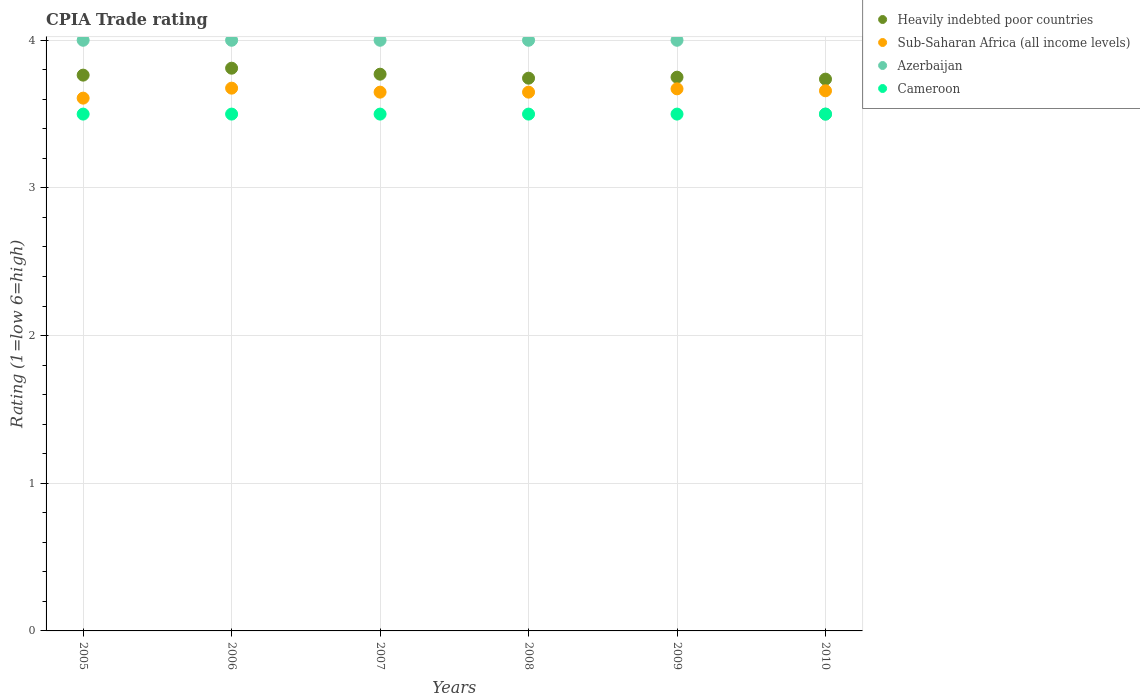How many different coloured dotlines are there?
Your answer should be very brief. 4. Is the number of dotlines equal to the number of legend labels?
Give a very brief answer. Yes. What is the CPIA rating in Heavily indebted poor countries in 2010?
Give a very brief answer. 3.74. Across all years, what is the maximum CPIA rating in Heavily indebted poor countries?
Your answer should be very brief. 3.81. Across all years, what is the minimum CPIA rating in Sub-Saharan Africa (all income levels)?
Offer a very short reply. 3.61. What is the total CPIA rating in Sub-Saharan Africa (all income levels) in the graph?
Ensure brevity in your answer.  21.91. What is the difference between the CPIA rating in Heavily indebted poor countries in 2006 and that in 2008?
Make the answer very short. 0.07. What is the difference between the CPIA rating in Heavily indebted poor countries in 2007 and the CPIA rating in Cameroon in 2010?
Your answer should be compact. 0.27. What is the average CPIA rating in Azerbaijan per year?
Your response must be concise. 3.92. In the year 2010, what is the difference between the CPIA rating in Heavily indebted poor countries and CPIA rating in Azerbaijan?
Your answer should be very brief. 0.24. Is the CPIA rating in Cameroon strictly greater than the CPIA rating in Sub-Saharan Africa (all income levels) over the years?
Offer a very short reply. No. How many dotlines are there?
Ensure brevity in your answer.  4. How many years are there in the graph?
Give a very brief answer. 6. Are the values on the major ticks of Y-axis written in scientific E-notation?
Your answer should be very brief. No. How many legend labels are there?
Your response must be concise. 4. What is the title of the graph?
Provide a short and direct response. CPIA Trade rating. Does "India" appear as one of the legend labels in the graph?
Keep it short and to the point. No. What is the label or title of the X-axis?
Your answer should be compact. Years. What is the Rating (1=low 6=high) of Heavily indebted poor countries in 2005?
Offer a terse response. 3.76. What is the Rating (1=low 6=high) of Sub-Saharan Africa (all income levels) in 2005?
Give a very brief answer. 3.61. What is the Rating (1=low 6=high) in Heavily indebted poor countries in 2006?
Offer a terse response. 3.81. What is the Rating (1=low 6=high) of Sub-Saharan Africa (all income levels) in 2006?
Give a very brief answer. 3.68. What is the Rating (1=low 6=high) in Azerbaijan in 2006?
Your answer should be very brief. 4. What is the Rating (1=low 6=high) in Heavily indebted poor countries in 2007?
Give a very brief answer. 3.77. What is the Rating (1=low 6=high) of Sub-Saharan Africa (all income levels) in 2007?
Make the answer very short. 3.65. What is the Rating (1=low 6=high) of Cameroon in 2007?
Give a very brief answer. 3.5. What is the Rating (1=low 6=high) in Heavily indebted poor countries in 2008?
Your answer should be very brief. 3.74. What is the Rating (1=low 6=high) of Sub-Saharan Africa (all income levels) in 2008?
Keep it short and to the point. 3.65. What is the Rating (1=low 6=high) of Azerbaijan in 2008?
Give a very brief answer. 4. What is the Rating (1=low 6=high) of Cameroon in 2008?
Offer a terse response. 3.5. What is the Rating (1=low 6=high) in Heavily indebted poor countries in 2009?
Your response must be concise. 3.75. What is the Rating (1=low 6=high) of Sub-Saharan Africa (all income levels) in 2009?
Your answer should be compact. 3.67. What is the Rating (1=low 6=high) in Cameroon in 2009?
Offer a terse response. 3.5. What is the Rating (1=low 6=high) in Heavily indebted poor countries in 2010?
Ensure brevity in your answer.  3.74. What is the Rating (1=low 6=high) in Sub-Saharan Africa (all income levels) in 2010?
Your answer should be very brief. 3.66. What is the Rating (1=low 6=high) in Azerbaijan in 2010?
Provide a succinct answer. 3.5. What is the Rating (1=low 6=high) in Cameroon in 2010?
Your answer should be compact. 3.5. Across all years, what is the maximum Rating (1=low 6=high) of Heavily indebted poor countries?
Provide a short and direct response. 3.81. Across all years, what is the maximum Rating (1=low 6=high) of Sub-Saharan Africa (all income levels)?
Provide a short and direct response. 3.68. Across all years, what is the maximum Rating (1=low 6=high) in Azerbaijan?
Ensure brevity in your answer.  4. Across all years, what is the minimum Rating (1=low 6=high) in Heavily indebted poor countries?
Provide a succinct answer. 3.74. Across all years, what is the minimum Rating (1=low 6=high) in Sub-Saharan Africa (all income levels)?
Your response must be concise. 3.61. Across all years, what is the minimum Rating (1=low 6=high) of Azerbaijan?
Your response must be concise. 3.5. What is the total Rating (1=low 6=high) of Heavily indebted poor countries in the graph?
Keep it short and to the point. 22.58. What is the total Rating (1=low 6=high) in Sub-Saharan Africa (all income levels) in the graph?
Provide a short and direct response. 21.91. What is the total Rating (1=low 6=high) of Cameroon in the graph?
Give a very brief answer. 21. What is the difference between the Rating (1=low 6=high) of Heavily indebted poor countries in 2005 and that in 2006?
Your answer should be very brief. -0.05. What is the difference between the Rating (1=low 6=high) in Sub-Saharan Africa (all income levels) in 2005 and that in 2006?
Offer a very short reply. -0.07. What is the difference between the Rating (1=low 6=high) of Cameroon in 2005 and that in 2006?
Give a very brief answer. 0. What is the difference between the Rating (1=low 6=high) of Heavily indebted poor countries in 2005 and that in 2007?
Your response must be concise. -0.01. What is the difference between the Rating (1=low 6=high) of Sub-Saharan Africa (all income levels) in 2005 and that in 2007?
Give a very brief answer. -0.04. What is the difference between the Rating (1=low 6=high) in Cameroon in 2005 and that in 2007?
Ensure brevity in your answer.  0. What is the difference between the Rating (1=low 6=high) of Heavily indebted poor countries in 2005 and that in 2008?
Give a very brief answer. 0.02. What is the difference between the Rating (1=low 6=high) of Sub-Saharan Africa (all income levels) in 2005 and that in 2008?
Your response must be concise. -0.04. What is the difference between the Rating (1=low 6=high) of Azerbaijan in 2005 and that in 2008?
Ensure brevity in your answer.  0. What is the difference between the Rating (1=low 6=high) of Heavily indebted poor countries in 2005 and that in 2009?
Keep it short and to the point. 0.01. What is the difference between the Rating (1=low 6=high) of Sub-Saharan Africa (all income levels) in 2005 and that in 2009?
Your answer should be compact. -0.06. What is the difference between the Rating (1=low 6=high) in Azerbaijan in 2005 and that in 2009?
Keep it short and to the point. 0. What is the difference between the Rating (1=low 6=high) in Heavily indebted poor countries in 2005 and that in 2010?
Offer a very short reply. 0.03. What is the difference between the Rating (1=low 6=high) of Sub-Saharan Africa (all income levels) in 2005 and that in 2010?
Your answer should be very brief. -0.05. What is the difference between the Rating (1=low 6=high) in Azerbaijan in 2005 and that in 2010?
Your answer should be very brief. 0.5. What is the difference between the Rating (1=low 6=high) of Heavily indebted poor countries in 2006 and that in 2007?
Give a very brief answer. 0.04. What is the difference between the Rating (1=low 6=high) of Sub-Saharan Africa (all income levels) in 2006 and that in 2007?
Give a very brief answer. 0.03. What is the difference between the Rating (1=low 6=high) of Azerbaijan in 2006 and that in 2007?
Keep it short and to the point. 0. What is the difference between the Rating (1=low 6=high) of Cameroon in 2006 and that in 2007?
Your answer should be compact. 0. What is the difference between the Rating (1=low 6=high) of Heavily indebted poor countries in 2006 and that in 2008?
Your answer should be very brief. 0.07. What is the difference between the Rating (1=low 6=high) of Sub-Saharan Africa (all income levels) in 2006 and that in 2008?
Make the answer very short. 0.03. What is the difference between the Rating (1=low 6=high) of Heavily indebted poor countries in 2006 and that in 2009?
Your answer should be very brief. 0.06. What is the difference between the Rating (1=low 6=high) in Sub-Saharan Africa (all income levels) in 2006 and that in 2009?
Offer a terse response. 0. What is the difference between the Rating (1=low 6=high) of Heavily indebted poor countries in 2006 and that in 2010?
Provide a short and direct response. 0.07. What is the difference between the Rating (1=low 6=high) of Sub-Saharan Africa (all income levels) in 2006 and that in 2010?
Ensure brevity in your answer.  0.02. What is the difference between the Rating (1=low 6=high) in Heavily indebted poor countries in 2007 and that in 2008?
Your answer should be compact. 0.03. What is the difference between the Rating (1=low 6=high) in Azerbaijan in 2007 and that in 2008?
Keep it short and to the point. 0. What is the difference between the Rating (1=low 6=high) in Heavily indebted poor countries in 2007 and that in 2009?
Your response must be concise. 0.02. What is the difference between the Rating (1=low 6=high) in Sub-Saharan Africa (all income levels) in 2007 and that in 2009?
Provide a succinct answer. -0.02. What is the difference between the Rating (1=low 6=high) in Azerbaijan in 2007 and that in 2009?
Your answer should be compact. 0. What is the difference between the Rating (1=low 6=high) in Cameroon in 2007 and that in 2009?
Your response must be concise. 0. What is the difference between the Rating (1=low 6=high) in Heavily indebted poor countries in 2007 and that in 2010?
Keep it short and to the point. 0.03. What is the difference between the Rating (1=low 6=high) of Sub-Saharan Africa (all income levels) in 2007 and that in 2010?
Make the answer very short. -0.01. What is the difference between the Rating (1=low 6=high) in Azerbaijan in 2007 and that in 2010?
Your answer should be very brief. 0.5. What is the difference between the Rating (1=low 6=high) of Heavily indebted poor countries in 2008 and that in 2009?
Ensure brevity in your answer.  -0.01. What is the difference between the Rating (1=low 6=high) of Sub-Saharan Africa (all income levels) in 2008 and that in 2009?
Ensure brevity in your answer.  -0.02. What is the difference between the Rating (1=low 6=high) in Azerbaijan in 2008 and that in 2009?
Provide a short and direct response. 0. What is the difference between the Rating (1=low 6=high) in Heavily indebted poor countries in 2008 and that in 2010?
Your answer should be compact. 0.01. What is the difference between the Rating (1=low 6=high) of Sub-Saharan Africa (all income levels) in 2008 and that in 2010?
Ensure brevity in your answer.  -0.01. What is the difference between the Rating (1=low 6=high) of Azerbaijan in 2008 and that in 2010?
Your response must be concise. 0.5. What is the difference between the Rating (1=low 6=high) of Heavily indebted poor countries in 2009 and that in 2010?
Offer a very short reply. 0.01. What is the difference between the Rating (1=low 6=high) of Sub-Saharan Africa (all income levels) in 2009 and that in 2010?
Give a very brief answer. 0.01. What is the difference between the Rating (1=low 6=high) in Azerbaijan in 2009 and that in 2010?
Your answer should be compact. 0.5. What is the difference between the Rating (1=low 6=high) of Cameroon in 2009 and that in 2010?
Your answer should be compact. 0. What is the difference between the Rating (1=low 6=high) of Heavily indebted poor countries in 2005 and the Rating (1=low 6=high) of Sub-Saharan Africa (all income levels) in 2006?
Offer a very short reply. 0.09. What is the difference between the Rating (1=low 6=high) in Heavily indebted poor countries in 2005 and the Rating (1=low 6=high) in Azerbaijan in 2006?
Give a very brief answer. -0.24. What is the difference between the Rating (1=low 6=high) of Heavily indebted poor countries in 2005 and the Rating (1=low 6=high) of Cameroon in 2006?
Keep it short and to the point. 0.26. What is the difference between the Rating (1=low 6=high) in Sub-Saharan Africa (all income levels) in 2005 and the Rating (1=low 6=high) in Azerbaijan in 2006?
Give a very brief answer. -0.39. What is the difference between the Rating (1=low 6=high) of Sub-Saharan Africa (all income levels) in 2005 and the Rating (1=low 6=high) of Cameroon in 2006?
Keep it short and to the point. 0.11. What is the difference between the Rating (1=low 6=high) in Azerbaijan in 2005 and the Rating (1=low 6=high) in Cameroon in 2006?
Offer a terse response. 0.5. What is the difference between the Rating (1=low 6=high) of Heavily indebted poor countries in 2005 and the Rating (1=low 6=high) of Sub-Saharan Africa (all income levels) in 2007?
Offer a very short reply. 0.12. What is the difference between the Rating (1=low 6=high) in Heavily indebted poor countries in 2005 and the Rating (1=low 6=high) in Azerbaijan in 2007?
Your response must be concise. -0.24. What is the difference between the Rating (1=low 6=high) in Heavily indebted poor countries in 2005 and the Rating (1=low 6=high) in Cameroon in 2007?
Give a very brief answer. 0.26. What is the difference between the Rating (1=low 6=high) of Sub-Saharan Africa (all income levels) in 2005 and the Rating (1=low 6=high) of Azerbaijan in 2007?
Provide a succinct answer. -0.39. What is the difference between the Rating (1=low 6=high) of Sub-Saharan Africa (all income levels) in 2005 and the Rating (1=low 6=high) of Cameroon in 2007?
Keep it short and to the point. 0.11. What is the difference between the Rating (1=low 6=high) in Heavily indebted poor countries in 2005 and the Rating (1=low 6=high) in Sub-Saharan Africa (all income levels) in 2008?
Provide a succinct answer. 0.12. What is the difference between the Rating (1=low 6=high) of Heavily indebted poor countries in 2005 and the Rating (1=low 6=high) of Azerbaijan in 2008?
Offer a terse response. -0.24. What is the difference between the Rating (1=low 6=high) of Heavily indebted poor countries in 2005 and the Rating (1=low 6=high) of Cameroon in 2008?
Provide a succinct answer. 0.26. What is the difference between the Rating (1=low 6=high) in Sub-Saharan Africa (all income levels) in 2005 and the Rating (1=low 6=high) in Azerbaijan in 2008?
Your answer should be very brief. -0.39. What is the difference between the Rating (1=low 6=high) of Sub-Saharan Africa (all income levels) in 2005 and the Rating (1=low 6=high) of Cameroon in 2008?
Give a very brief answer. 0.11. What is the difference between the Rating (1=low 6=high) of Azerbaijan in 2005 and the Rating (1=low 6=high) of Cameroon in 2008?
Provide a short and direct response. 0.5. What is the difference between the Rating (1=low 6=high) of Heavily indebted poor countries in 2005 and the Rating (1=low 6=high) of Sub-Saharan Africa (all income levels) in 2009?
Offer a very short reply. 0.09. What is the difference between the Rating (1=low 6=high) in Heavily indebted poor countries in 2005 and the Rating (1=low 6=high) in Azerbaijan in 2009?
Give a very brief answer. -0.24. What is the difference between the Rating (1=low 6=high) in Heavily indebted poor countries in 2005 and the Rating (1=low 6=high) in Cameroon in 2009?
Your answer should be very brief. 0.26. What is the difference between the Rating (1=low 6=high) of Sub-Saharan Africa (all income levels) in 2005 and the Rating (1=low 6=high) of Azerbaijan in 2009?
Provide a short and direct response. -0.39. What is the difference between the Rating (1=low 6=high) in Sub-Saharan Africa (all income levels) in 2005 and the Rating (1=low 6=high) in Cameroon in 2009?
Your answer should be very brief. 0.11. What is the difference between the Rating (1=low 6=high) of Azerbaijan in 2005 and the Rating (1=low 6=high) of Cameroon in 2009?
Ensure brevity in your answer.  0.5. What is the difference between the Rating (1=low 6=high) of Heavily indebted poor countries in 2005 and the Rating (1=low 6=high) of Sub-Saharan Africa (all income levels) in 2010?
Provide a short and direct response. 0.11. What is the difference between the Rating (1=low 6=high) in Heavily indebted poor countries in 2005 and the Rating (1=low 6=high) in Azerbaijan in 2010?
Your response must be concise. 0.26. What is the difference between the Rating (1=low 6=high) in Heavily indebted poor countries in 2005 and the Rating (1=low 6=high) in Cameroon in 2010?
Provide a short and direct response. 0.26. What is the difference between the Rating (1=low 6=high) in Sub-Saharan Africa (all income levels) in 2005 and the Rating (1=low 6=high) in Azerbaijan in 2010?
Provide a succinct answer. 0.11. What is the difference between the Rating (1=low 6=high) in Sub-Saharan Africa (all income levels) in 2005 and the Rating (1=low 6=high) in Cameroon in 2010?
Offer a very short reply. 0.11. What is the difference between the Rating (1=low 6=high) of Azerbaijan in 2005 and the Rating (1=low 6=high) of Cameroon in 2010?
Offer a very short reply. 0.5. What is the difference between the Rating (1=low 6=high) in Heavily indebted poor countries in 2006 and the Rating (1=low 6=high) in Sub-Saharan Africa (all income levels) in 2007?
Keep it short and to the point. 0.16. What is the difference between the Rating (1=low 6=high) of Heavily indebted poor countries in 2006 and the Rating (1=low 6=high) of Azerbaijan in 2007?
Keep it short and to the point. -0.19. What is the difference between the Rating (1=low 6=high) in Heavily indebted poor countries in 2006 and the Rating (1=low 6=high) in Cameroon in 2007?
Provide a succinct answer. 0.31. What is the difference between the Rating (1=low 6=high) in Sub-Saharan Africa (all income levels) in 2006 and the Rating (1=low 6=high) in Azerbaijan in 2007?
Offer a very short reply. -0.32. What is the difference between the Rating (1=low 6=high) in Sub-Saharan Africa (all income levels) in 2006 and the Rating (1=low 6=high) in Cameroon in 2007?
Provide a short and direct response. 0.18. What is the difference between the Rating (1=low 6=high) in Azerbaijan in 2006 and the Rating (1=low 6=high) in Cameroon in 2007?
Give a very brief answer. 0.5. What is the difference between the Rating (1=low 6=high) of Heavily indebted poor countries in 2006 and the Rating (1=low 6=high) of Sub-Saharan Africa (all income levels) in 2008?
Keep it short and to the point. 0.16. What is the difference between the Rating (1=low 6=high) of Heavily indebted poor countries in 2006 and the Rating (1=low 6=high) of Azerbaijan in 2008?
Provide a succinct answer. -0.19. What is the difference between the Rating (1=low 6=high) in Heavily indebted poor countries in 2006 and the Rating (1=low 6=high) in Cameroon in 2008?
Offer a terse response. 0.31. What is the difference between the Rating (1=low 6=high) in Sub-Saharan Africa (all income levels) in 2006 and the Rating (1=low 6=high) in Azerbaijan in 2008?
Make the answer very short. -0.32. What is the difference between the Rating (1=low 6=high) of Sub-Saharan Africa (all income levels) in 2006 and the Rating (1=low 6=high) of Cameroon in 2008?
Your response must be concise. 0.18. What is the difference between the Rating (1=low 6=high) in Heavily indebted poor countries in 2006 and the Rating (1=low 6=high) in Sub-Saharan Africa (all income levels) in 2009?
Provide a succinct answer. 0.14. What is the difference between the Rating (1=low 6=high) in Heavily indebted poor countries in 2006 and the Rating (1=low 6=high) in Azerbaijan in 2009?
Provide a short and direct response. -0.19. What is the difference between the Rating (1=low 6=high) of Heavily indebted poor countries in 2006 and the Rating (1=low 6=high) of Cameroon in 2009?
Provide a short and direct response. 0.31. What is the difference between the Rating (1=low 6=high) of Sub-Saharan Africa (all income levels) in 2006 and the Rating (1=low 6=high) of Azerbaijan in 2009?
Offer a terse response. -0.32. What is the difference between the Rating (1=low 6=high) in Sub-Saharan Africa (all income levels) in 2006 and the Rating (1=low 6=high) in Cameroon in 2009?
Provide a succinct answer. 0.18. What is the difference between the Rating (1=low 6=high) of Heavily indebted poor countries in 2006 and the Rating (1=low 6=high) of Sub-Saharan Africa (all income levels) in 2010?
Your response must be concise. 0.15. What is the difference between the Rating (1=low 6=high) of Heavily indebted poor countries in 2006 and the Rating (1=low 6=high) of Azerbaijan in 2010?
Provide a succinct answer. 0.31. What is the difference between the Rating (1=low 6=high) in Heavily indebted poor countries in 2006 and the Rating (1=low 6=high) in Cameroon in 2010?
Your answer should be very brief. 0.31. What is the difference between the Rating (1=low 6=high) in Sub-Saharan Africa (all income levels) in 2006 and the Rating (1=low 6=high) in Azerbaijan in 2010?
Keep it short and to the point. 0.18. What is the difference between the Rating (1=low 6=high) in Sub-Saharan Africa (all income levels) in 2006 and the Rating (1=low 6=high) in Cameroon in 2010?
Your answer should be very brief. 0.18. What is the difference between the Rating (1=low 6=high) in Azerbaijan in 2006 and the Rating (1=low 6=high) in Cameroon in 2010?
Make the answer very short. 0.5. What is the difference between the Rating (1=low 6=high) of Heavily indebted poor countries in 2007 and the Rating (1=low 6=high) of Sub-Saharan Africa (all income levels) in 2008?
Provide a succinct answer. 0.12. What is the difference between the Rating (1=low 6=high) of Heavily indebted poor countries in 2007 and the Rating (1=low 6=high) of Azerbaijan in 2008?
Provide a succinct answer. -0.23. What is the difference between the Rating (1=low 6=high) in Heavily indebted poor countries in 2007 and the Rating (1=low 6=high) in Cameroon in 2008?
Provide a succinct answer. 0.27. What is the difference between the Rating (1=low 6=high) in Sub-Saharan Africa (all income levels) in 2007 and the Rating (1=low 6=high) in Azerbaijan in 2008?
Offer a terse response. -0.35. What is the difference between the Rating (1=low 6=high) of Sub-Saharan Africa (all income levels) in 2007 and the Rating (1=low 6=high) of Cameroon in 2008?
Give a very brief answer. 0.15. What is the difference between the Rating (1=low 6=high) in Azerbaijan in 2007 and the Rating (1=low 6=high) in Cameroon in 2008?
Offer a terse response. 0.5. What is the difference between the Rating (1=low 6=high) of Heavily indebted poor countries in 2007 and the Rating (1=low 6=high) of Sub-Saharan Africa (all income levels) in 2009?
Keep it short and to the point. 0.1. What is the difference between the Rating (1=low 6=high) of Heavily indebted poor countries in 2007 and the Rating (1=low 6=high) of Azerbaijan in 2009?
Provide a succinct answer. -0.23. What is the difference between the Rating (1=low 6=high) of Heavily indebted poor countries in 2007 and the Rating (1=low 6=high) of Cameroon in 2009?
Your response must be concise. 0.27. What is the difference between the Rating (1=low 6=high) of Sub-Saharan Africa (all income levels) in 2007 and the Rating (1=low 6=high) of Azerbaijan in 2009?
Give a very brief answer. -0.35. What is the difference between the Rating (1=low 6=high) in Sub-Saharan Africa (all income levels) in 2007 and the Rating (1=low 6=high) in Cameroon in 2009?
Offer a very short reply. 0.15. What is the difference between the Rating (1=low 6=high) of Heavily indebted poor countries in 2007 and the Rating (1=low 6=high) of Sub-Saharan Africa (all income levels) in 2010?
Provide a succinct answer. 0.11. What is the difference between the Rating (1=low 6=high) of Heavily indebted poor countries in 2007 and the Rating (1=low 6=high) of Azerbaijan in 2010?
Give a very brief answer. 0.27. What is the difference between the Rating (1=low 6=high) in Heavily indebted poor countries in 2007 and the Rating (1=low 6=high) in Cameroon in 2010?
Your answer should be compact. 0.27. What is the difference between the Rating (1=low 6=high) of Sub-Saharan Africa (all income levels) in 2007 and the Rating (1=low 6=high) of Azerbaijan in 2010?
Offer a terse response. 0.15. What is the difference between the Rating (1=low 6=high) of Sub-Saharan Africa (all income levels) in 2007 and the Rating (1=low 6=high) of Cameroon in 2010?
Your response must be concise. 0.15. What is the difference between the Rating (1=low 6=high) in Heavily indebted poor countries in 2008 and the Rating (1=low 6=high) in Sub-Saharan Africa (all income levels) in 2009?
Your answer should be very brief. 0.07. What is the difference between the Rating (1=low 6=high) in Heavily indebted poor countries in 2008 and the Rating (1=low 6=high) in Azerbaijan in 2009?
Your answer should be very brief. -0.26. What is the difference between the Rating (1=low 6=high) in Heavily indebted poor countries in 2008 and the Rating (1=low 6=high) in Cameroon in 2009?
Offer a very short reply. 0.24. What is the difference between the Rating (1=low 6=high) in Sub-Saharan Africa (all income levels) in 2008 and the Rating (1=low 6=high) in Azerbaijan in 2009?
Your answer should be compact. -0.35. What is the difference between the Rating (1=low 6=high) of Sub-Saharan Africa (all income levels) in 2008 and the Rating (1=low 6=high) of Cameroon in 2009?
Your response must be concise. 0.15. What is the difference between the Rating (1=low 6=high) of Azerbaijan in 2008 and the Rating (1=low 6=high) of Cameroon in 2009?
Provide a short and direct response. 0.5. What is the difference between the Rating (1=low 6=high) of Heavily indebted poor countries in 2008 and the Rating (1=low 6=high) of Sub-Saharan Africa (all income levels) in 2010?
Offer a very short reply. 0.09. What is the difference between the Rating (1=low 6=high) of Heavily indebted poor countries in 2008 and the Rating (1=low 6=high) of Azerbaijan in 2010?
Your answer should be very brief. 0.24. What is the difference between the Rating (1=low 6=high) of Heavily indebted poor countries in 2008 and the Rating (1=low 6=high) of Cameroon in 2010?
Your response must be concise. 0.24. What is the difference between the Rating (1=low 6=high) in Sub-Saharan Africa (all income levels) in 2008 and the Rating (1=low 6=high) in Azerbaijan in 2010?
Ensure brevity in your answer.  0.15. What is the difference between the Rating (1=low 6=high) of Sub-Saharan Africa (all income levels) in 2008 and the Rating (1=low 6=high) of Cameroon in 2010?
Give a very brief answer. 0.15. What is the difference between the Rating (1=low 6=high) in Heavily indebted poor countries in 2009 and the Rating (1=low 6=high) in Sub-Saharan Africa (all income levels) in 2010?
Your answer should be very brief. 0.09. What is the difference between the Rating (1=low 6=high) of Heavily indebted poor countries in 2009 and the Rating (1=low 6=high) of Cameroon in 2010?
Provide a succinct answer. 0.25. What is the difference between the Rating (1=low 6=high) of Sub-Saharan Africa (all income levels) in 2009 and the Rating (1=low 6=high) of Azerbaijan in 2010?
Your answer should be very brief. 0.17. What is the difference between the Rating (1=low 6=high) in Sub-Saharan Africa (all income levels) in 2009 and the Rating (1=low 6=high) in Cameroon in 2010?
Offer a terse response. 0.17. What is the difference between the Rating (1=low 6=high) in Azerbaijan in 2009 and the Rating (1=low 6=high) in Cameroon in 2010?
Provide a succinct answer. 0.5. What is the average Rating (1=low 6=high) of Heavily indebted poor countries per year?
Your response must be concise. 3.76. What is the average Rating (1=low 6=high) in Sub-Saharan Africa (all income levels) per year?
Give a very brief answer. 3.65. What is the average Rating (1=low 6=high) in Azerbaijan per year?
Your answer should be very brief. 3.92. In the year 2005, what is the difference between the Rating (1=low 6=high) of Heavily indebted poor countries and Rating (1=low 6=high) of Sub-Saharan Africa (all income levels)?
Your response must be concise. 0.16. In the year 2005, what is the difference between the Rating (1=low 6=high) of Heavily indebted poor countries and Rating (1=low 6=high) of Azerbaijan?
Provide a short and direct response. -0.24. In the year 2005, what is the difference between the Rating (1=low 6=high) of Heavily indebted poor countries and Rating (1=low 6=high) of Cameroon?
Offer a terse response. 0.26. In the year 2005, what is the difference between the Rating (1=low 6=high) of Sub-Saharan Africa (all income levels) and Rating (1=low 6=high) of Azerbaijan?
Ensure brevity in your answer.  -0.39. In the year 2005, what is the difference between the Rating (1=low 6=high) in Sub-Saharan Africa (all income levels) and Rating (1=low 6=high) in Cameroon?
Offer a very short reply. 0.11. In the year 2006, what is the difference between the Rating (1=low 6=high) in Heavily indebted poor countries and Rating (1=low 6=high) in Sub-Saharan Africa (all income levels)?
Give a very brief answer. 0.14. In the year 2006, what is the difference between the Rating (1=low 6=high) in Heavily indebted poor countries and Rating (1=low 6=high) in Azerbaijan?
Make the answer very short. -0.19. In the year 2006, what is the difference between the Rating (1=low 6=high) in Heavily indebted poor countries and Rating (1=low 6=high) in Cameroon?
Give a very brief answer. 0.31. In the year 2006, what is the difference between the Rating (1=low 6=high) of Sub-Saharan Africa (all income levels) and Rating (1=low 6=high) of Azerbaijan?
Give a very brief answer. -0.32. In the year 2006, what is the difference between the Rating (1=low 6=high) of Sub-Saharan Africa (all income levels) and Rating (1=low 6=high) of Cameroon?
Provide a succinct answer. 0.18. In the year 2006, what is the difference between the Rating (1=low 6=high) in Azerbaijan and Rating (1=low 6=high) in Cameroon?
Your response must be concise. 0.5. In the year 2007, what is the difference between the Rating (1=low 6=high) of Heavily indebted poor countries and Rating (1=low 6=high) of Sub-Saharan Africa (all income levels)?
Give a very brief answer. 0.12. In the year 2007, what is the difference between the Rating (1=low 6=high) in Heavily indebted poor countries and Rating (1=low 6=high) in Azerbaijan?
Make the answer very short. -0.23. In the year 2007, what is the difference between the Rating (1=low 6=high) of Heavily indebted poor countries and Rating (1=low 6=high) of Cameroon?
Your answer should be very brief. 0.27. In the year 2007, what is the difference between the Rating (1=low 6=high) of Sub-Saharan Africa (all income levels) and Rating (1=low 6=high) of Azerbaijan?
Give a very brief answer. -0.35. In the year 2007, what is the difference between the Rating (1=low 6=high) in Sub-Saharan Africa (all income levels) and Rating (1=low 6=high) in Cameroon?
Your answer should be very brief. 0.15. In the year 2008, what is the difference between the Rating (1=low 6=high) of Heavily indebted poor countries and Rating (1=low 6=high) of Sub-Saharan Africa (all income levels)?
Ensure brevity in your answer.  0.09. In the year 2008, what is the difference between the Rating (1=low 6=high) of Heavily indebted poor countries and Rating (1=low 6=high) of Azerbaijan?
Offer a very short reply. -0.26. In the year 2008, what is the difference between the Rating (1=low 6=high) in Heavily indebted poor countries and Rating (1=low 6=high) in Cameroon?
Offer a terse response. 0.24. In the year 2008, what is the difference between the Rating (1=low 6=high) in Sub-Saharan Africa (all income levels) and Rating (1=low 6=high) in Azerbaijan?
Offer a very short reply. -0.35. In the year 2008, what is the difference between the Rating (1=low 6=high) of Sub-Saharan Africa (all income levels) and Rating (1=low 6=high) of Cameroon?
Keep it short and to the point. 0.15. In the year 2008, what is the difference between the Rating (1=low 6=high) of Azerbaijan and Rating (1=low 6=high) of Cameroon?
Offer a terse response. 0.5. In the year 2009, what is the difference between the Rating (1=low 6=high) of Heavily indebted poor countries and Rating (1=low 6=high) of Sub-Saharan Africa (all income levels)?
Offer a terse response. 0.08. In the year 2009, what is the difference between the Rating (1=low 6=high) in Heavily indebted poor countries and Rating (1=low 6=high) in Cameroon?
Keep it short and to the point. 0.25. In the year 2009, what is the difference between the Rating (1=low 6=high) of Sub-Saharan Africa (all income levels) and Rating (1=low 6=high) of Azerbaijan?
Ensure brevity in your answer.  -0.33. In the year 2009, what is the difference between the Rating (1=low 6=high) in Sub-Saharan Africa (all income levels) and Rating (1=low 6=high) in Cameroon?
Make the answer very short. 0.17. In the year 2010, what is the difference between the Rating (1=low 6=high) in Heavily indebted poor countries and Rating (1=low 6=high) in Sub-Saharan Africa (all income levels)?
Ensure brevity in your answer.  0.08. In the year 2010, what is the difference between the Rating (1=low 6=high) in Heavily indebted poor countries and Rating (1=low 6=high) in Azerbaijan?
Your answer should be compact. 0.24. In the year 2010, what is the difference between the Rating (1=low 6=high) of Heavily indebted poor countries and Rating (1=low 6=high) of Cameroon?
Provide a short and direct response. 0.24. In the year 2010, what is the difference between the Rating (1=low 6=high) of Sub-Saharan Africa (all income levels) and Rating (1=low 6=high) of Azerbaijan?
Ensure brevity in your answer.  0.16. In the year 2010, what is the difference between the Rating (1=low 6=high) of Sub-Saharan Africa (all income levels) and Rating (1=low 6=high) of Cameroon?
Ensure brevity in your answer.  0.16. What is the ratio of the Rating (1=low 6=high) of Heavily indebted poor countries in 2005 to that in 2006?
Provide a short and direct response. 0.99. What is the ratio of the Rating (1=low 6=high) in Sub-Saharan Africa (all income levels) in 2005 to that in 2006?
Your answer should be very brief. 0.98. What is the ratio of the Rating (1=low 6=high) in Azerbaijan in 2005 to that in 2006?
Your answer should be compact. 1. What is the ratio of the Rating (1=low 6=high) in Sub-Saharan Africa (all income levels) in 2005 to that in 2007?
Your answer should be compact. 0.99. What is the ratio of the Rating (1=low 6=high) in Cameroon in 2005 to that in 2007?
Your response must be concise. 1. What is the ratio of the Rating (1=low 6=high) of Sub-Saharan Africa (all income levels) in 2005 to that in 2008?
Ensure brevity in your answer.  0.99. What is the ratio of the Rating (1=low 6=high) of Heavily indebted poor countries in 2005 to that in 2009?
Offer a terse response. 1. What is the ratio of the Rating (1=low 6=high) in Sub-Saharan Africa (all income levels) in 2005 to that in 2009?
Your answer should be very brief. 0.98. What is the ratio of the Rating (1=low 6=high) in Cameroon in 2005 to that in 2009?
Your answer should be very brief. 1. What is the ratio of the Rating (1=low 6=high) of Sub-Saharan Africa (all income levels) in 2005 to that in 2010?
Ensure brevity in your answer.  0.99. What is the ratio of the Rating (1=low 6=high) of Azerbaijan in 2005 to that in 2010?
Keep it short and to the point. 1.14. What is the ratio of the Rating (1=low 6=high) in Heavily indebted poor countries in 2006 to that in 2007?
Your answer should be very brief. 1.01. What is the ratio of the Rating (1=low 6=high) in Sub-Saharan Africa (all income levels) in 2006 to that in 2007?
Your answer should be compact. 1.01. What is the ratio of the Rating (1=low 6=high) in Heavily indebted poor countries in 2006 to that in 2008?
Make the answer very short. 1.02. What is the ratio of the Rating (1=low 6=high) of Sub-Saharan Africa (all income levels) in 2006 to that in 2008?
Make the answer very short. 1.01. What is the ratio of the Rating (1=low 6=high) of Azerbaijan in 2006 to that in 2008?
Your response must be concise. 1. What is the ratio of the Rating (1=low 6=high) in Heavily indebted poor countries in 2006 to that in 2009?
Ensure brevity in your answer.  1.02. What is the ratio of the Rating (1=low 6=high) of Sub-Saharan Africa (all income levels) in 2006 to that in 2009?
Ensure brevity in your answer.  1. What is the ratio of the Rating (1=low 6=high) of Heavily indebted poor countries in 2006 to that in 2010?
Give a very brief answer. 1.02. What is the ratio of the Rating (1=low 6=high) of Sub-Saharan Africa (all income levels) in 2006 to that in 2010?
Offer a very short reply. 1. What is the ratio of the Rating (1=low 6=high) in Azerbaijan in 2006 to that in 2010?
Your response must be concise. 1.14. What is the ratio of the Rating (1=low 6=high) in Cameroon in 2006 to that in 2010?
Ensure brevity in your answer.  1. What is the ratio of the Rating (1=low 6=high) in Heavily indebted poor countries in 2007 to that in 2008?
Your response must be concise. 1.01. What is the ratio of the Rating (1=low 6=high) in Cameroon in 2007 to that in 2008?
Provide a short and direct response. 1. What is the ratio of the Rating (1=low 6=high) of Heavily indebted poor countries in 2007 to that in 2009?
Keep it short and to the point. 1.01. What is the ratio of the Rating (1=low 6=high) in Heavily indebted poor countries in 2007 to that in 2010?
Your answer should be compact. 1.01. What is the ratio of the Rating (1=low 6=high) of Azerbaijan in 2007 to that in 2010?
Keep it short and to the point. 1.14. What is the ratio of the Rating (1=low 6=high) in Heavily indebted poor countries in 2008 to that in 2009?
Keep it short and to the point. 1. What is the ratio of the Rating (1=low 6=high) in Azerbaijan in 2008 to that in 2009?
Provide a short and direct response. 1. What is the ratio of the Rating (1=low 6=high) in Cameroon in 2008 to that in 2009?
Your answer should be very brief. 1. What is the ratio of the Rating (1=low 6=high) of Heavily indebted poor countries in 2008 to that in 2010?
Keep it short and to the point. 1. What is the ratio of the Rating (1=low 6=high) of Sub-Saharan Africa (all income levels) in 2008 to that in 2010?
Offer a very short reply. 1. What is the ratio of the Rating (1=low 6=high) of Azerbaijan in 2008 to that in 2010?
Provide a short and direct response. 1.14. What is the difference between the highest and the second highest Rating (1=low 6=high) in Heavily indebted poor countries?
Make the answer very short. 0.04. What is the difference between the highest and the second highest Rating (1=low 6=high) of Sub-Saharan Africa (all income levels)?
Offer a very short reply. 0. What is the difference between the highest and the second highest Rating (1=low 6=high) in Azerbaijan?
Provide a short and direct response. 0. What is the difference between the highest and the lowest Rating (1=low 6=high) in Heavily indebted poor countries?
Provide a succinct answer. 0.07. What is the difference between the highest and the lowest Rating (1=low 6=high) in Sub-Saharan Africa (all income levels)?
Your answer should be compact. 0.07. What is the difference between the highest and the lowest Rating (1=low 6=high) of Azerbaijan?
Keep it short and to the point. 0.5. What is the difference between the highest and the lowest Rating (1=low 6=high) in Cameroon?
Keep it short and to the point. 0. 